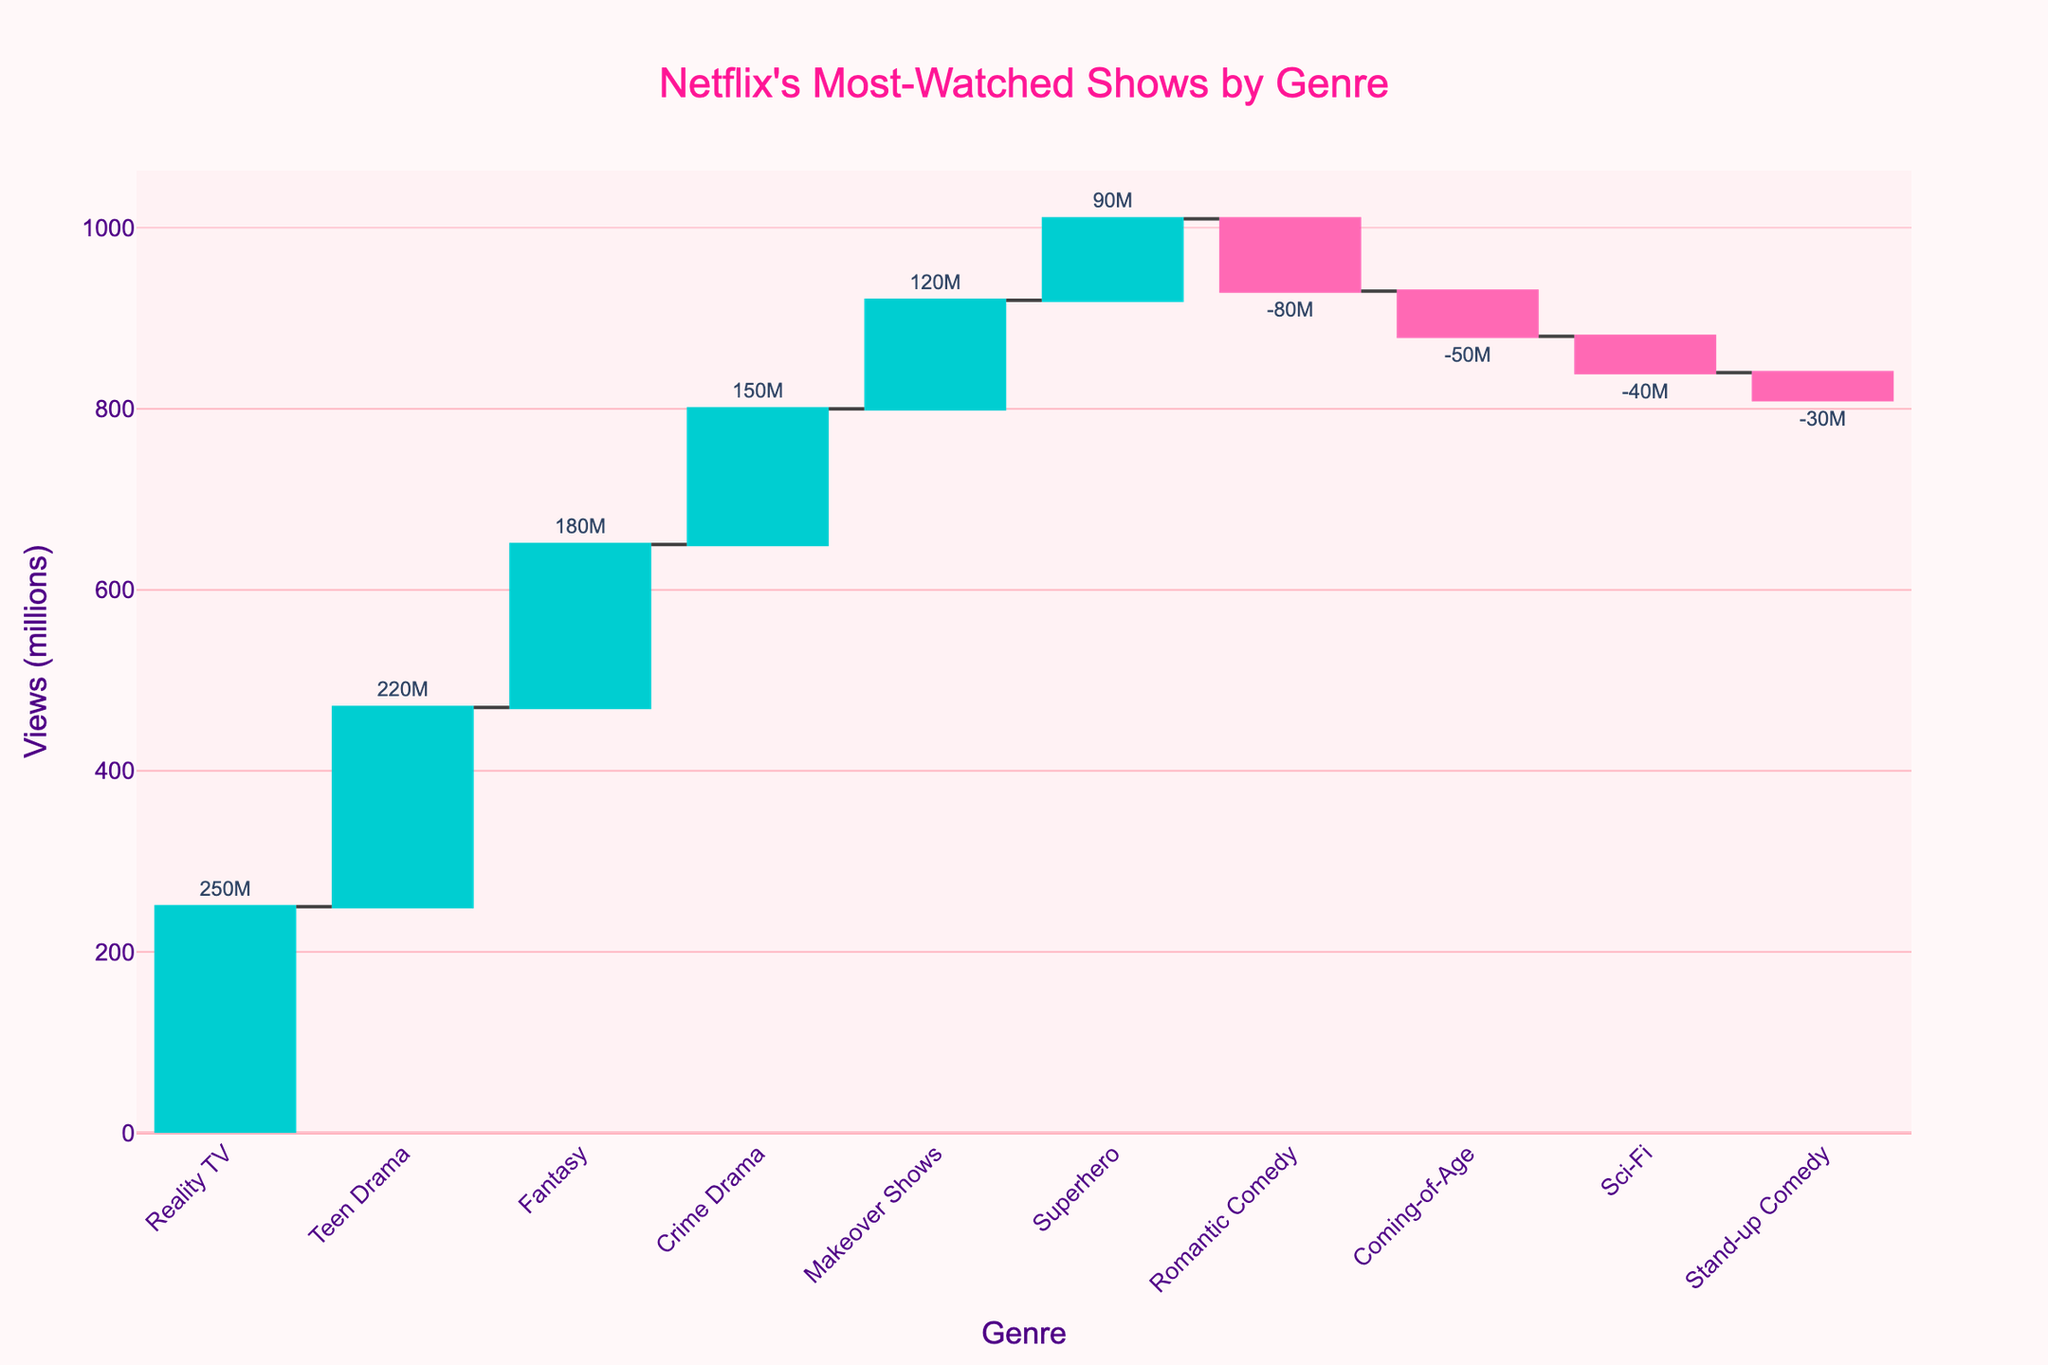What's the main title of the figure? The title is displayed at the top of the figure and provides an overview of what the figure is depicting.
Answer: Netflix's Most-Watched Shows by Genre What's the total number of data points shown in the figure? Each genre in the x-axis represents a data point, and we can count the number of different genres listed. There are 10 genre labels.
Answer: 10 What's the color used for the decreasing views? In the waterfall chart, color differentiation helps identify increasing and decreasing values. The bars for decreasing views are colored in pink.
Answer: Pink Which genre has the highest number of views? Observing the heights of the bars and the values displayed, the highest bar represents 'Reality TV' with 250 million views.
Answer: Reality TV Which genre has the lowest number of views? Observing the heights of the bars and the values displayed, the lowest bar represents 'Coming-of-Age' with -50 million views.
Answer: Coming-of-Age How many genres have negative views? By observing the bars that drop below the x-axis, corresponding to negative values, we count the genres: Romantic Comedy, Sci-Fi, Stand-up Comedy, and Coming-of-Age.
Answer: 4 What is the total combined views for 'Crime Drama' and 'Fantasy'? 'Crime Drama' has 150 million views and 'Fantasy' has 180 million views. Adding these together, 150 + 180 = 330 million.
Answer: 330 million How much more popular is 'Superhero' compared to 'Stand-up Comedy'? 'Superhero' has 90 million views, while 'Stand-up Comedy' has -30 million views. The difference is 90 - (-30) = 120 million.
Answer: 120 million If the genres with negative views were excluded, what would be the new total number of genres? Currently, there are 10 genres. Excluding the 4 with negative views leaves us with 10 - 4 = 6 genres.
Answer: 6 Which genre saw a decrease in views but is not the least popular? Looking at the negative values, 'Romantic Comedy', 'Sci-Fi', 'Stand-up Comedy', and 'Coming-of-Age' all decreased. Among them, 'Sci-Fi' with -40 million is not the least popular as 'Coming-of-Age' has -50 million views.
Answer: Sci-Fi 